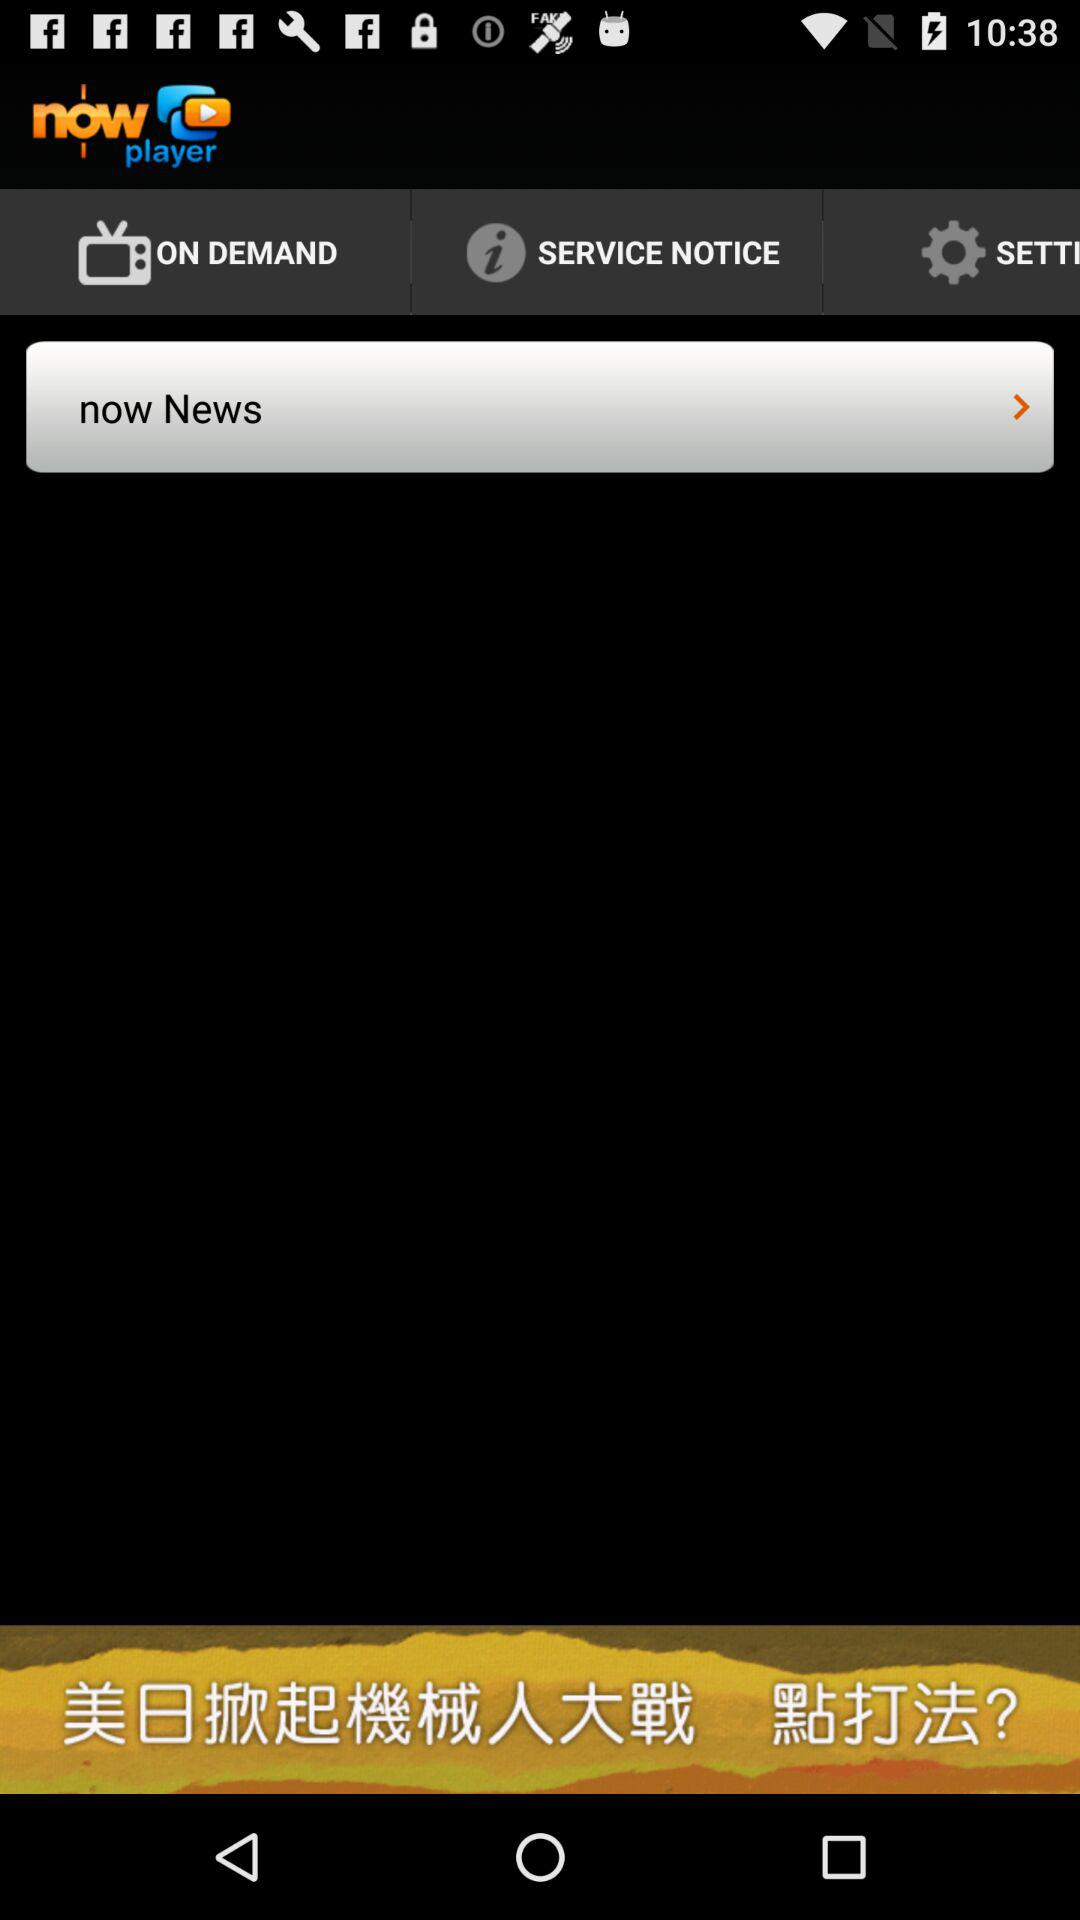What is the app name? The app name is "now player". 